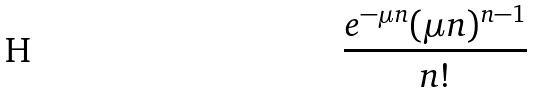Convert formula to latex. <formula><loc_0><loc_0><loc_500><loc_500>\frac { e ^ { - \mu n } ( \mu n ) ^ { n - 1 } } { n ! }</formula> 